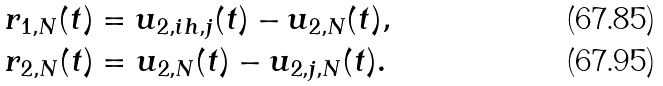Convert formula to latex. <formula><loc_0><loc_0><loc_500><loc_500>& r _ { 1 , N } ( t ) = u _ { 2 , i h , j } ( t ) - u _ { 2 , N } ( t ) , \\ & r _ { 2 , N } ( t ) = u _ { 2 , N } ( t ) - u _ { 2 , j , N } ( t ) .</formula> 